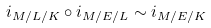<formula> <loc_0><loc_0><loc_500><loc_500>i _ { M / L / K } \circ i _ { M / E / L } \sim i _ { M / E / K }</formula> 